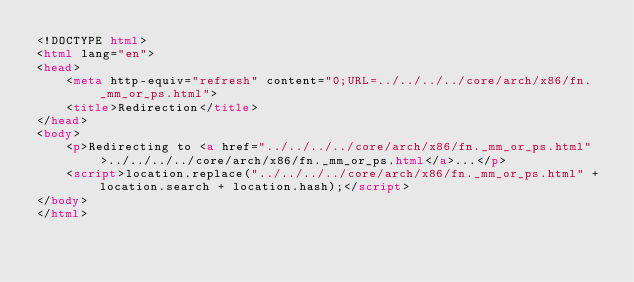Convert code to text. <code><loc_0><loc_0><loc_500><loc_500><_HTML_><!DOCTYPE html>
<html lang="en">
<head>
    <meta http-equiv="refresh" content="0;URL=../../../../core/arch/x86/fn._mm_or_ps.html">
    <title>Redirection</title>
</head>
<body>
    <p>Redirecting to <a href="../../../../core/arch/x86/fn._mm_or_ps.html">../../../../core/arch/x86/fn._mm_or_ps.html</a>...</p>
    <script>location.replace("../../../../core/arch/x86/fn._mm_or_ps.html" + location.search + location.hash);</script>
</body>
</html></code> 